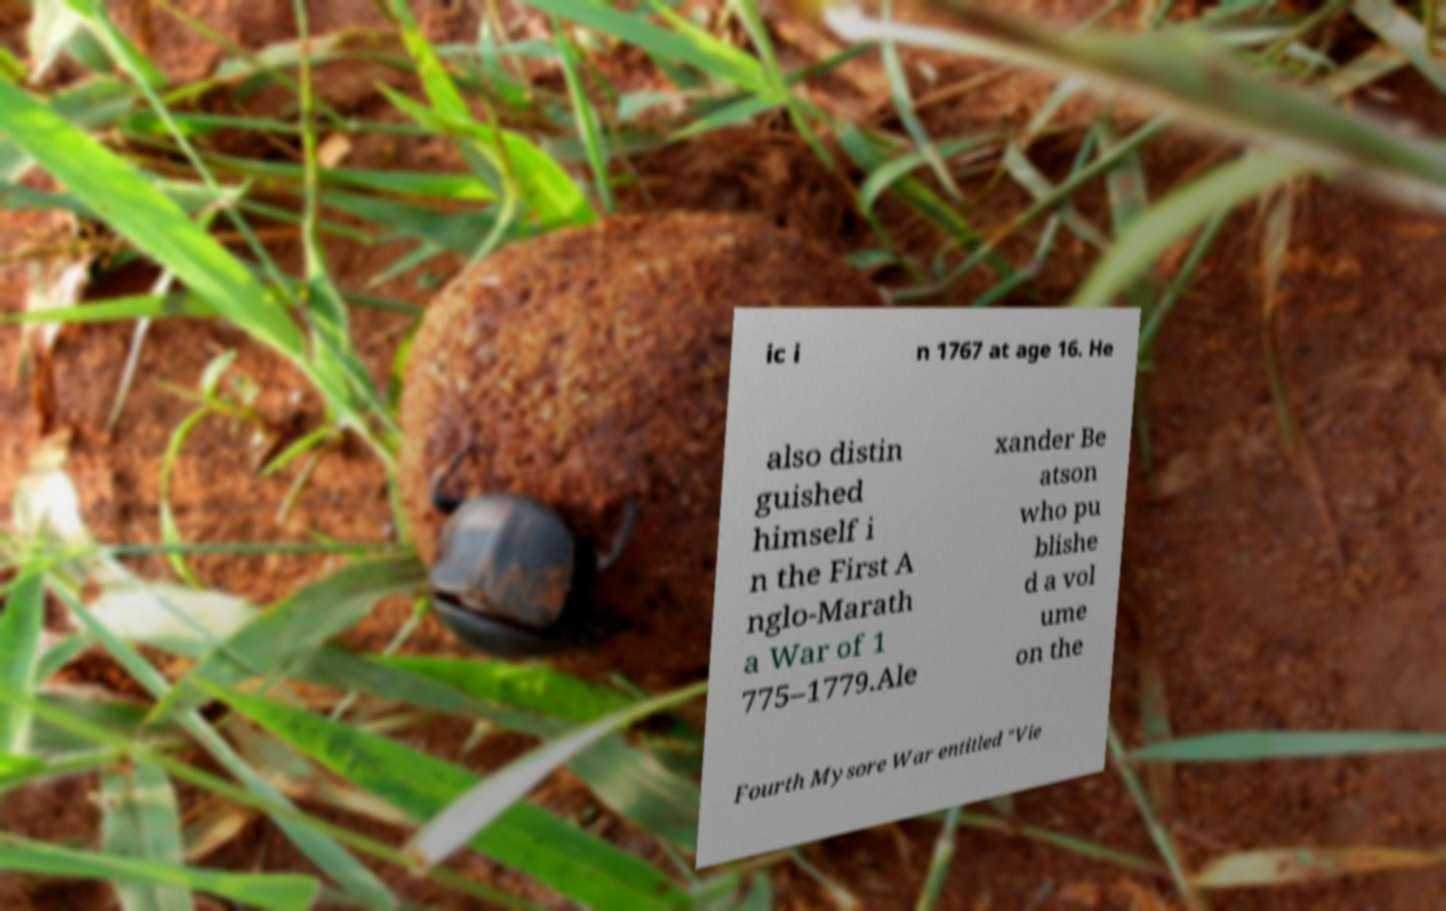Could you extract and type out the text from this image? ic i n 1767 at age 16. He also distin guished himself i n the First A nglo-Marath a War of 1 775–1779.Ale xander Be atson who pu blishe d a vol ume on the Fourth Mysore War entitled "Vie 